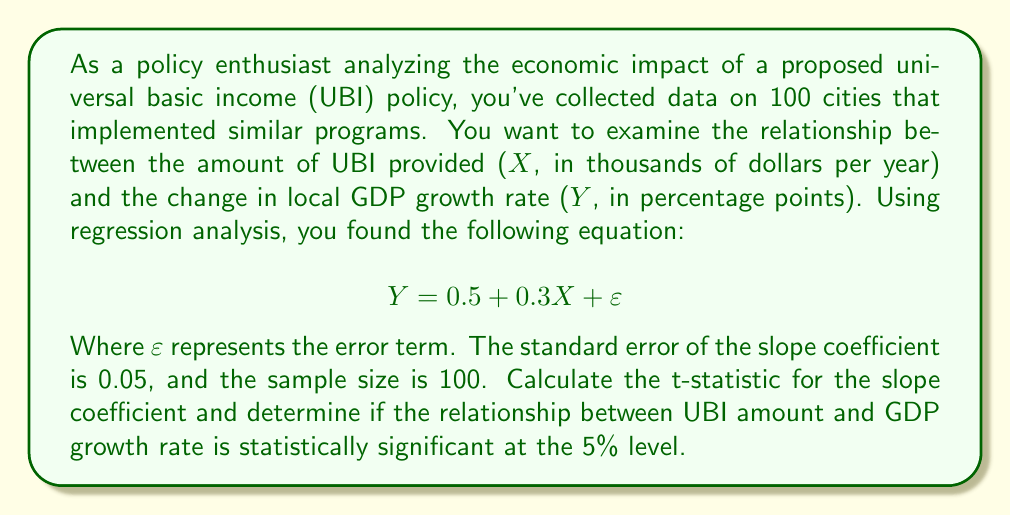Help me with this question. To determine if the relationship between UBI amount and GDP growth rate is statistically significant, we need to perform a hypothesis test using the t-statistic. Here's the step-by-step process:

1. Identify the slope coefficient and its standard error:
   Slope coefficient (β) = 0.3
   Standard error of β (SE_β) = 0.05

2. Calculate the t-statistic:
   The formula for the t-statistic is:
   $$ t = \frac{\beta}{SE_{\beta}} $$
   
   Plugging in the values:
   $$ t = \frac{0.3}{0.05} = 6 $$

3. Determine the degrees of freedom:
   Degrees of freedom (df) = n - 2, where n is the sample size
   df = 100 - 2 = 98

4. Find the critical t-value:
   For a two-tailed test at the 5% significance level with 98 degrees of freedom, the critical t-value is approximately ±1.984 (This can be found in a t-distribution table or using statistical software).

5. Compare the calculated t-statistic to the critical t-value:
   |6| > 1.984

6. Interpret the results:
   Since the absolute value of the calculated t-statistic (6) is greater than the critical t-value (1.984), we reject the null hypothesis that there is no relationship between UBI amount and GDP growth rate.

Therefore, we can conclude that the relationship between UBI amount and GDP growth rate is statistically significant at the 5% level.
Answer: The t-statistic is 6, and the relationship between UBI amount and GDP growth rate is statistically significant at the 5% level. 